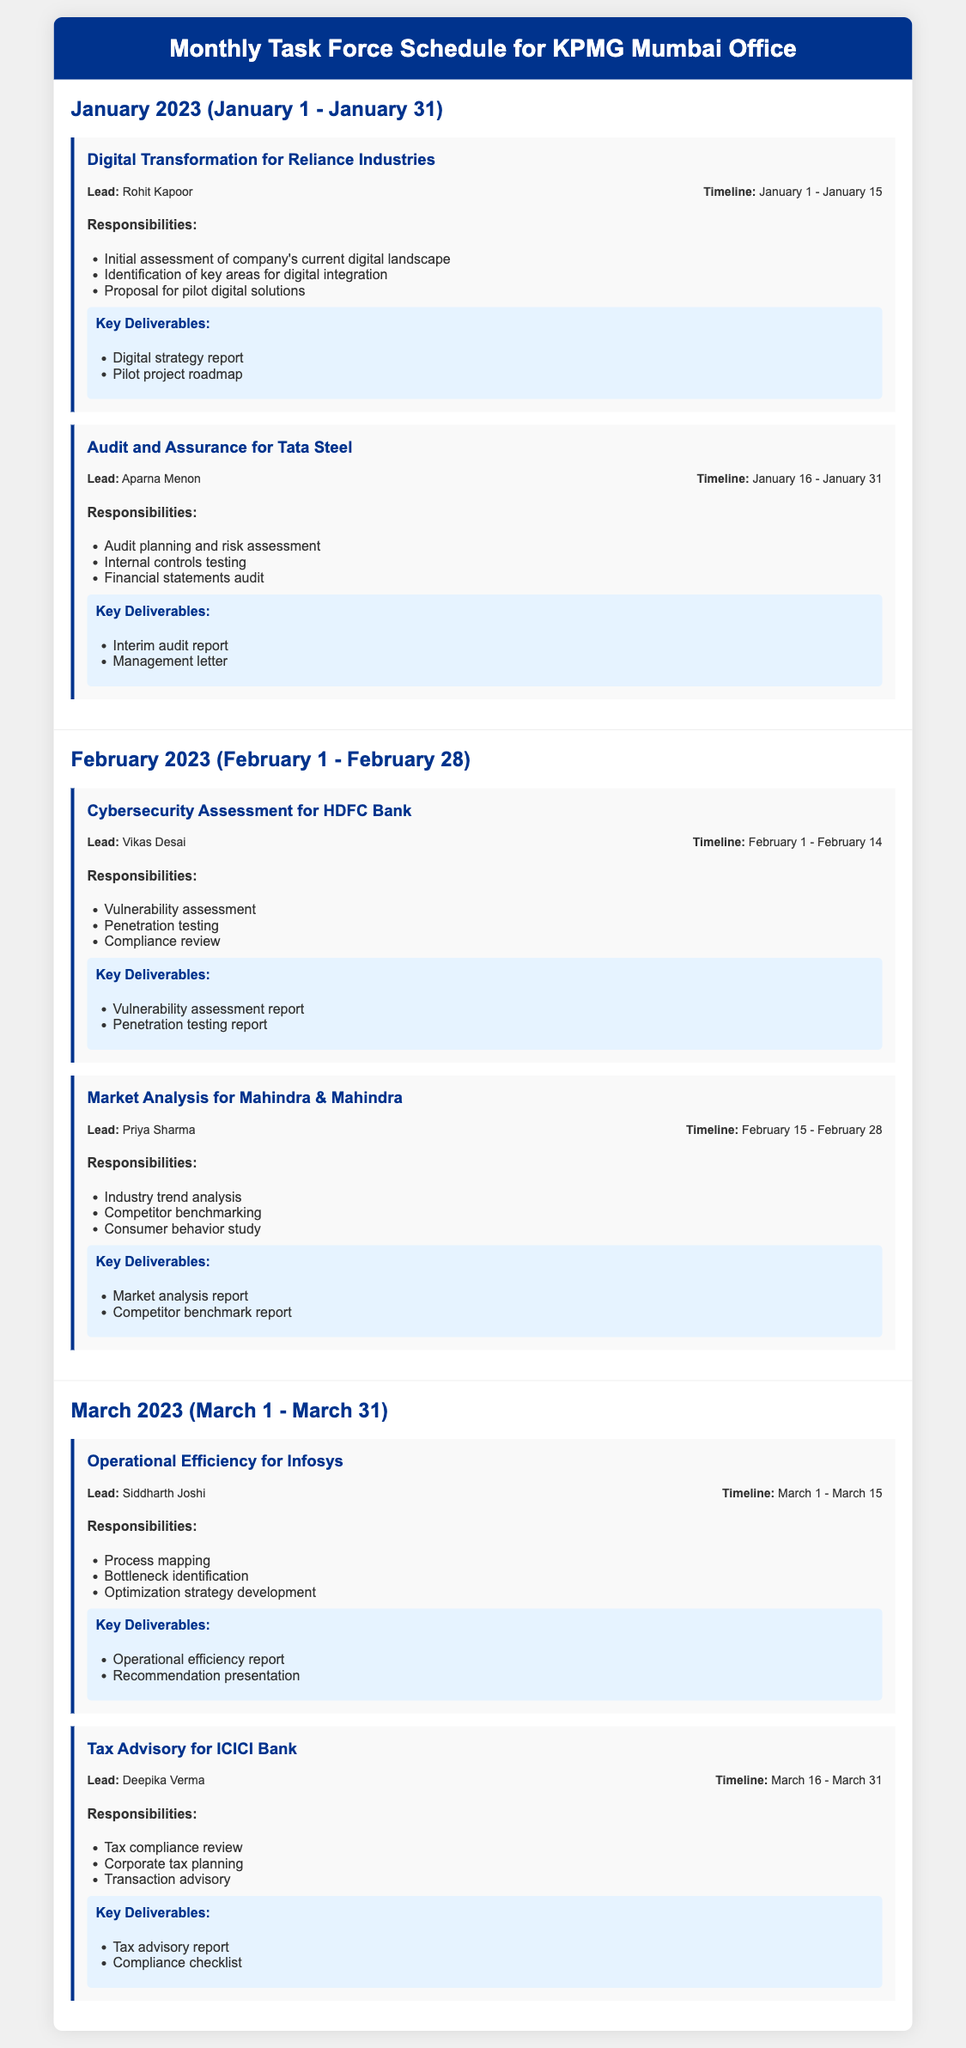What is the lead for the Digital Transformation for Reliance Industries project? The lead for this project is mentioned in the project section for Digital Transformation for Reliance Industries.
Answer: Rohit Kapoor What are the key deliverables for the Cybersecurity Assessment for HDFC Bank? The key deliverables are listed under the Cybersecurity Assessment project, summarizing the required outputs.
Answer: Vulnerability assessment report, Penetration testing report When does the Audit and Assurance for Tata Steel project start? The timeline for the Audit and Assurance for Tata Steel project provides the starting date of the project.
Answer: January 16 What is the main responsibility for the Market Analysis for Mahindra & Mahindra project? Main responsibilities are outlined under the responsibilities section for the Market Analysis project.
Answer: Industry trend analysis How many projects are listed for March 2023? The number of projects can be inferred by counting the project sections in the March 2023 part of the document.
Answer: 2 What is the duration of the Operational Efficiency for Infosys project? The timeline for Operational Efficiency for Infosys indicates the start and end dates, allowing for a calculation of the duration.
Answer: March 1 - March 15 Who is responsible for the Tax Advisory for ICICI Bank? The responsible person is explicitly named in the project details for Tax Advisory for ICICI Bank.
Answer: Deepika Verma What is the last deliverable for the Digital Transformation project? The last item in the deliverables section for Digital Transformation indicates the final deliverable expected.
Answer: Pilot project roadmap Which company is the focus of the project due on February 28? The project focus can be found in the Market Analysis for Mahindra & Mahindra project which is the last one in February.
Answer: Mahindra & Mahindra 